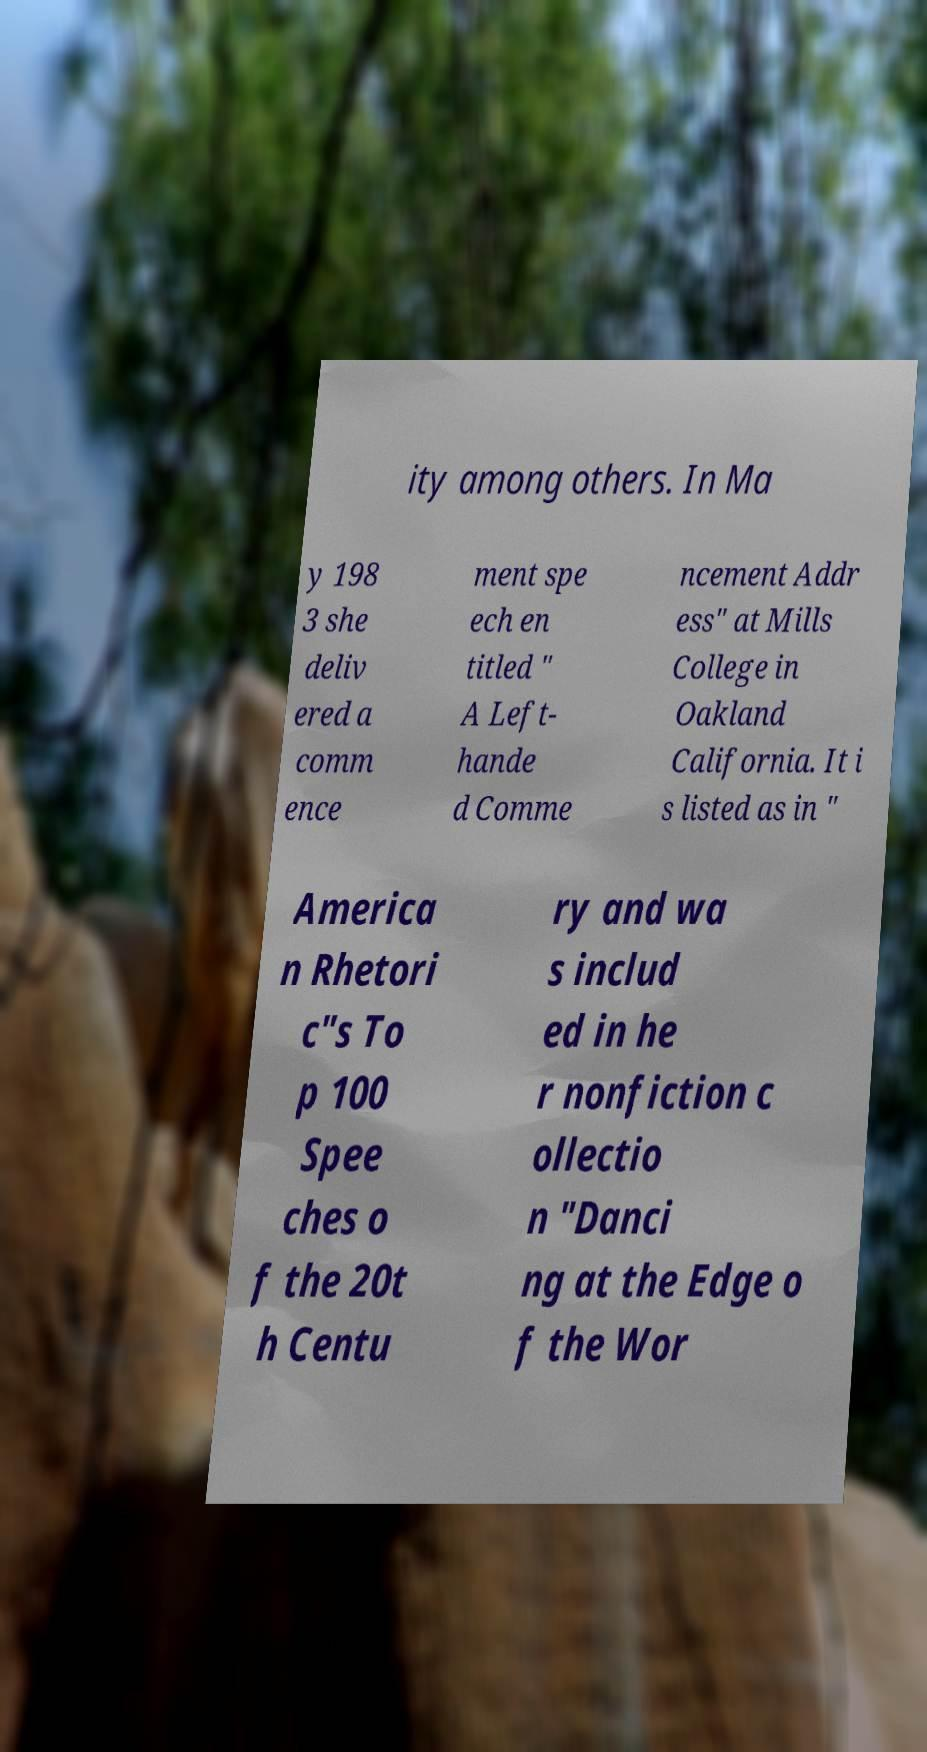Can you accurately transcribe the text from the provided image for me? ity among others. In Ma y 198 3 she deliv ered a comm ence ment spe ech en titled " A Left- hande d Comme ncement Addr ess" at Mills College in Oakland California. It i s listed as in " America n Rhetori c"s To p 100 Spee ches o f the 20t h Centu ry and wa s includ ed in he r nonfiction c ollectio n "Danci ng at the Edge o f the Wor 